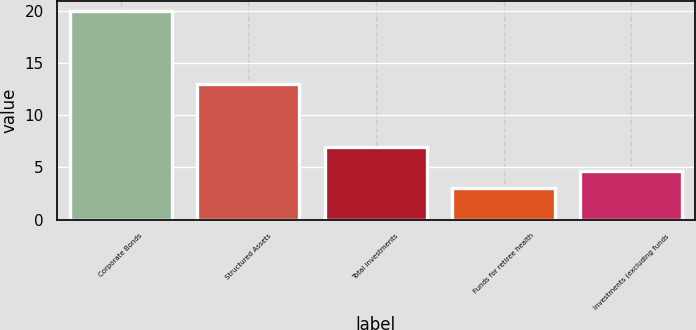Convert chart. <chart><loc_0><loc_0><loc_500><loc_500><bar_chart><fcel>Corporate Bonds<fcel>Structured Assets<fcel>Total investments<fcel>Funds for retiree health<fcel>Investments (excluding funds<nl><fcel>20<fcel>13<fcel>7<fcel>3<fcel>4.7<nl></chart> 